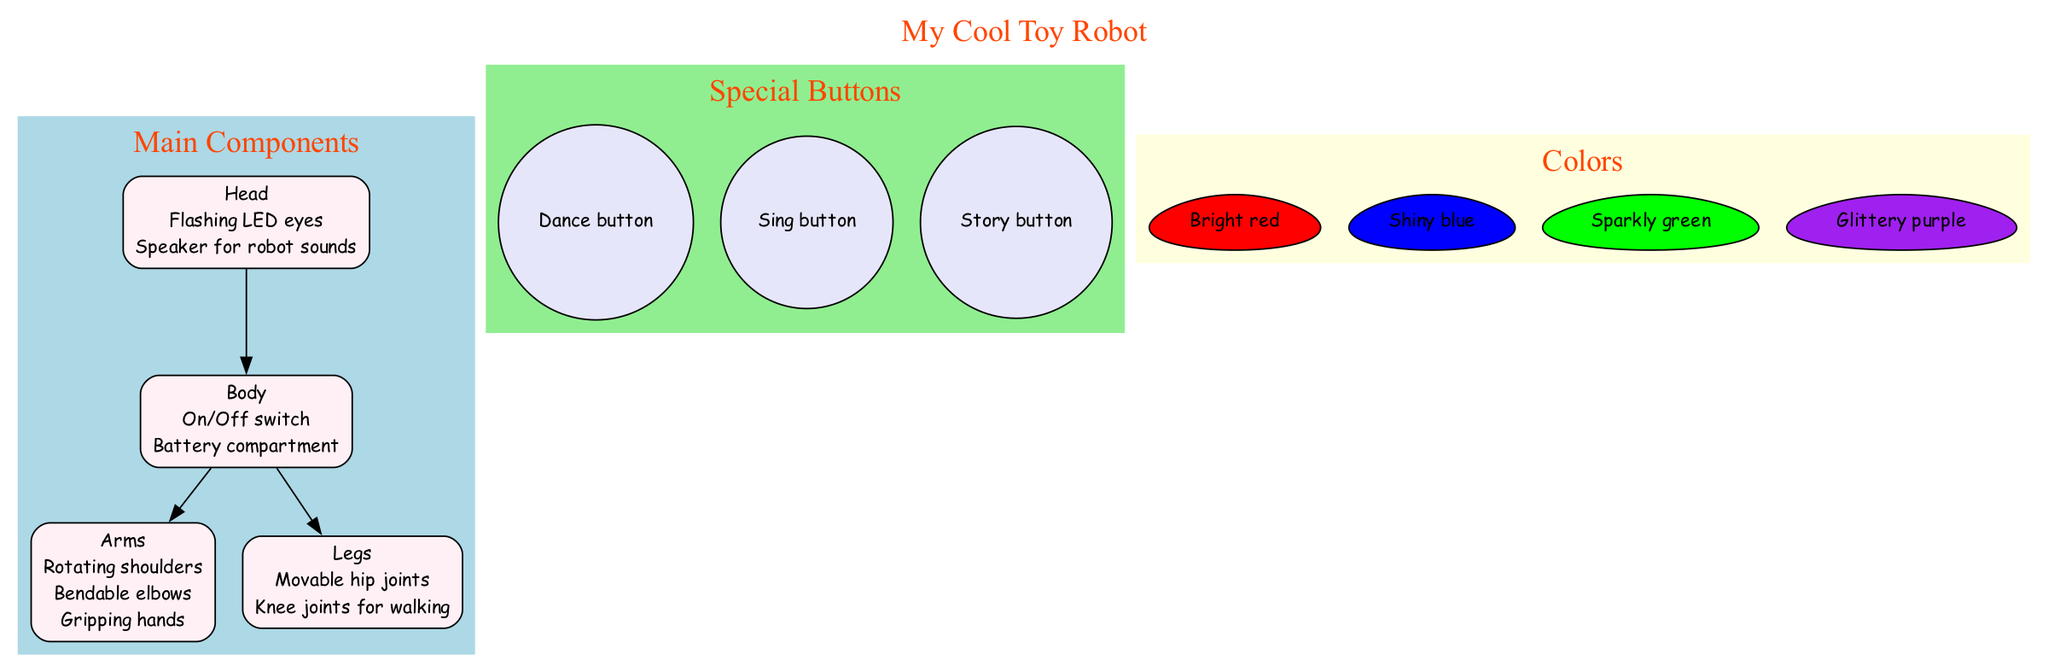What are the features of the Head? The Head has two features: Flashing LED eyes and Speaker for robot sounds. By looking at the node labeled "Head," we can see the information directly listed below it.
Answer: Flashing LED eyes, Speaker for robot sounds How many main components are there in the diagram? There are four main components identified: Head, Body, Arms, and Legs. Counting the nodes labeled under "Main Components," we find four distinct items.
Answer: 4 Which component of the robot has an On/Off switch? The Body component features the On/Off switch. This can be found by examining the features listed specifically under the node representing the Body.
Answer: Body What color is the Dance button? The Dance button is not directly shown as a color item; however, in the diagram, buttons are typically shown in light colors. It can be inferred that the buttons may share a color scheme similar to those indicated for sections in the diagram, as the color buttons have no specific color assigned.
Answer: Light color (inferred) How do the Arms connect to the Body in the diagram? The Arms are connected to the Body through a direct edge, illustrating that Arms are directly attached to or part of the Body. In the diagram, there is a line drawn from the Body to the Arms, indicating a relationship.
Answer: Direct edge Which features allow the Legs to move? The Legs have two features: Movable hip joints and Knee joints for walking. These features indicate how the Legs can articulate and allow movement. They are clearly listed under the Legs node.
Answer: Movable hip joints, Knee joints for walking What color is the Body section? The Body section is filled with a light color, specifically an off-white shade (#FFF0F5) as noted in the diagram. The fill color can be checked in the visual representational attributes of that node in the diagram.
Answer: Light color Which special button allows the robot to sing? The special button that allows the robot to sing is the Sing button. The buttons are clearly labeled in their section and can be directly identified.
Answer: Sing button 